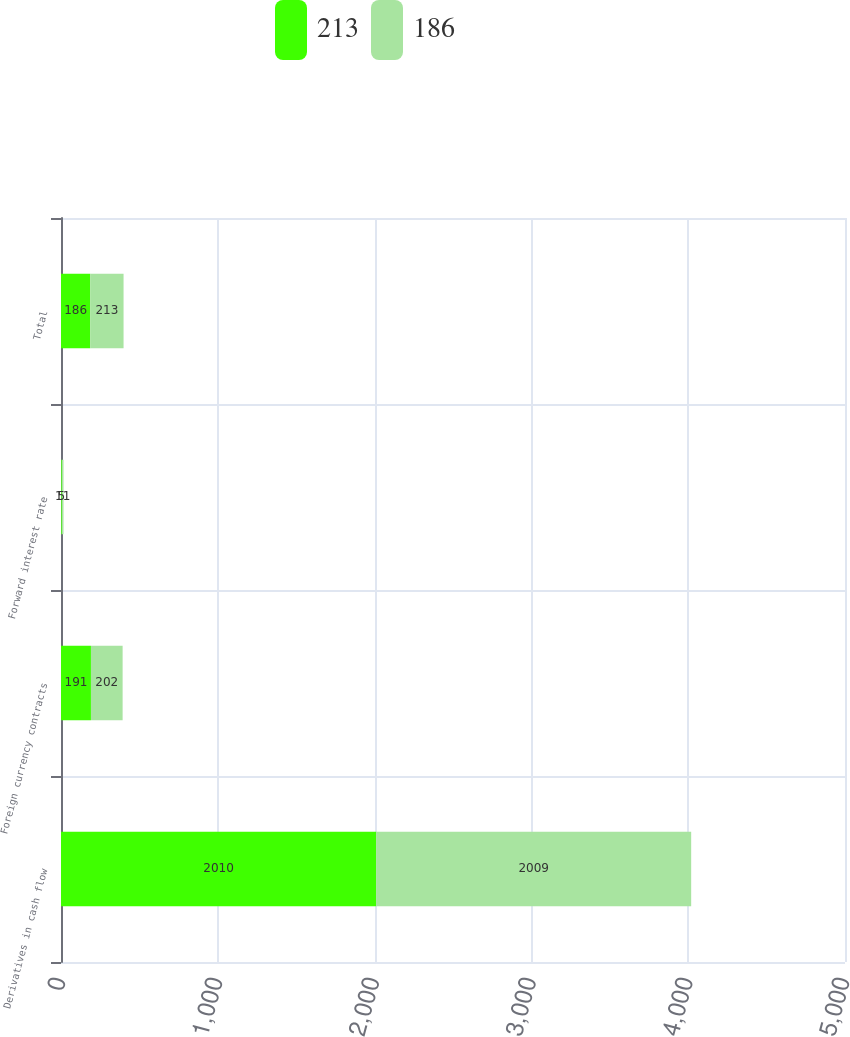Convert chart to OTSL. <chart><loc_0><loc_0><loc_500><loc_500><stacked_bar_chart><ecel><fcel>Derivatives in cash flow<fcel>Foreign currency contracts<fcel>Forward interest rate<fcel>Total<nl><fcel>213<fcel>2010<fcel>191<fcel>5<fcel>186<nl><fcel>186<fcel>2009<fcel>202<fcel>11<fcel>213<nl></chart> 